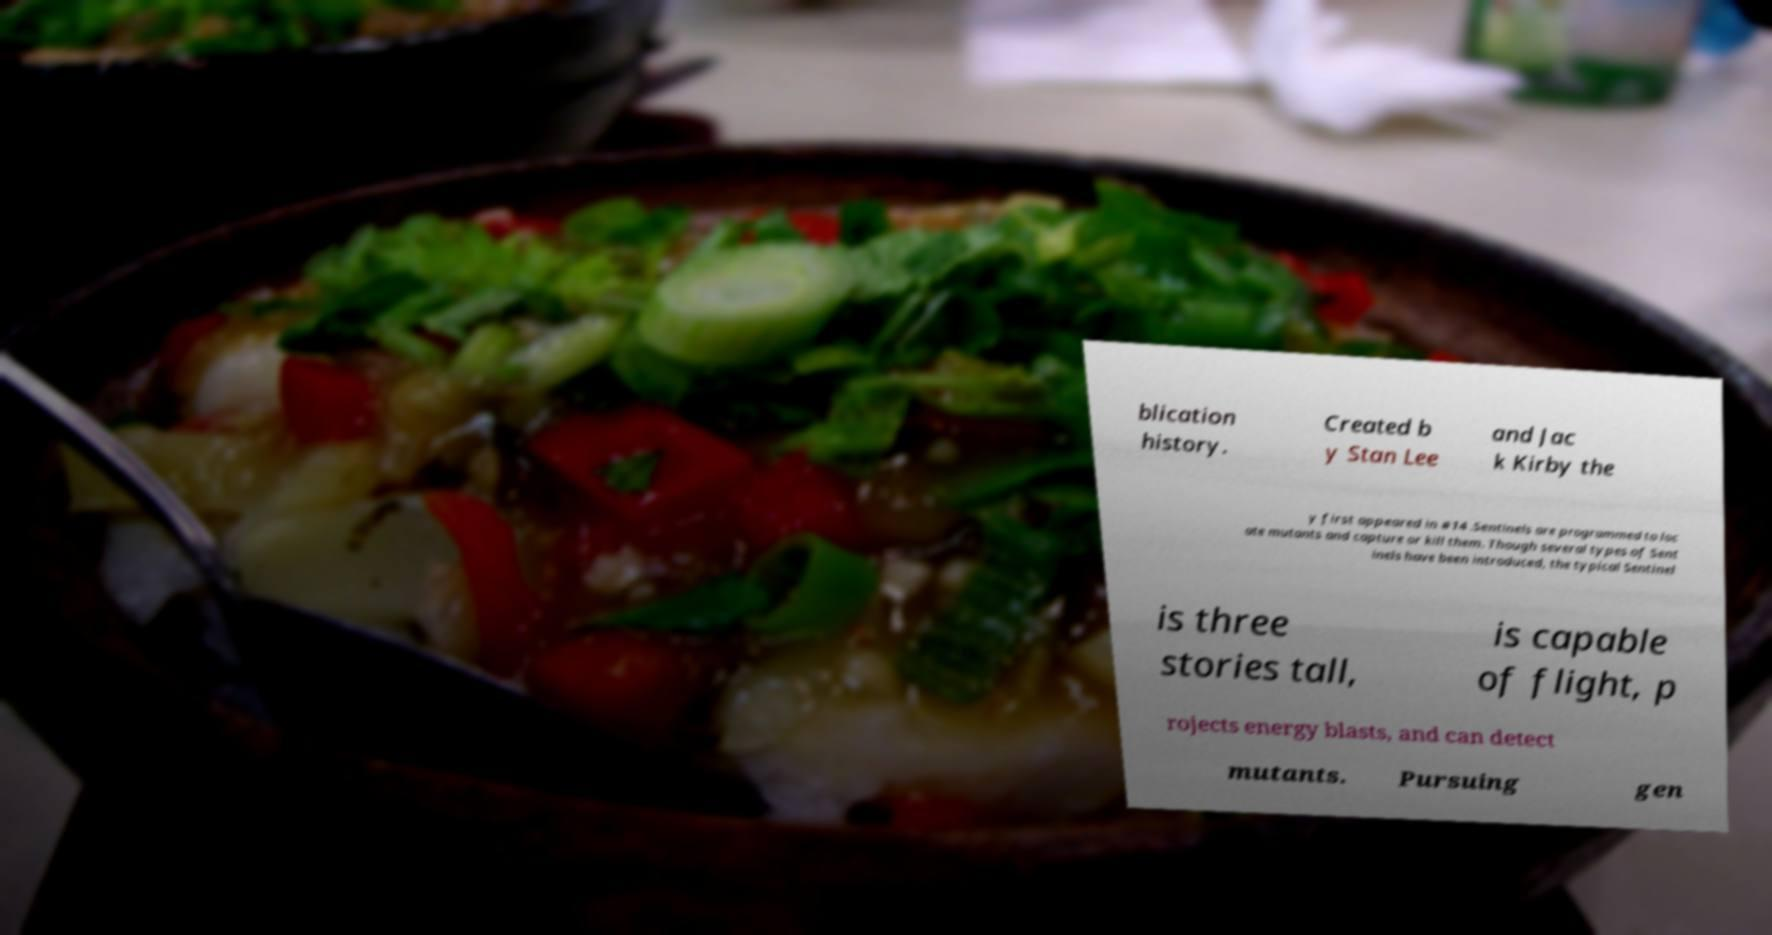Can you accurately transcribe the text from the provided image for me? blication history. Created b y Stan Lee and Jac k Kirby the y first appeared in #14 .Sentinels are programmed to loc ate mutants and capture or kill them. Though several types of Sent inels have been introduced, the typical Sentinel is three stories tall, is capable of flight, p rojects energy blasts, and can detect mutants. Pursuing gen 